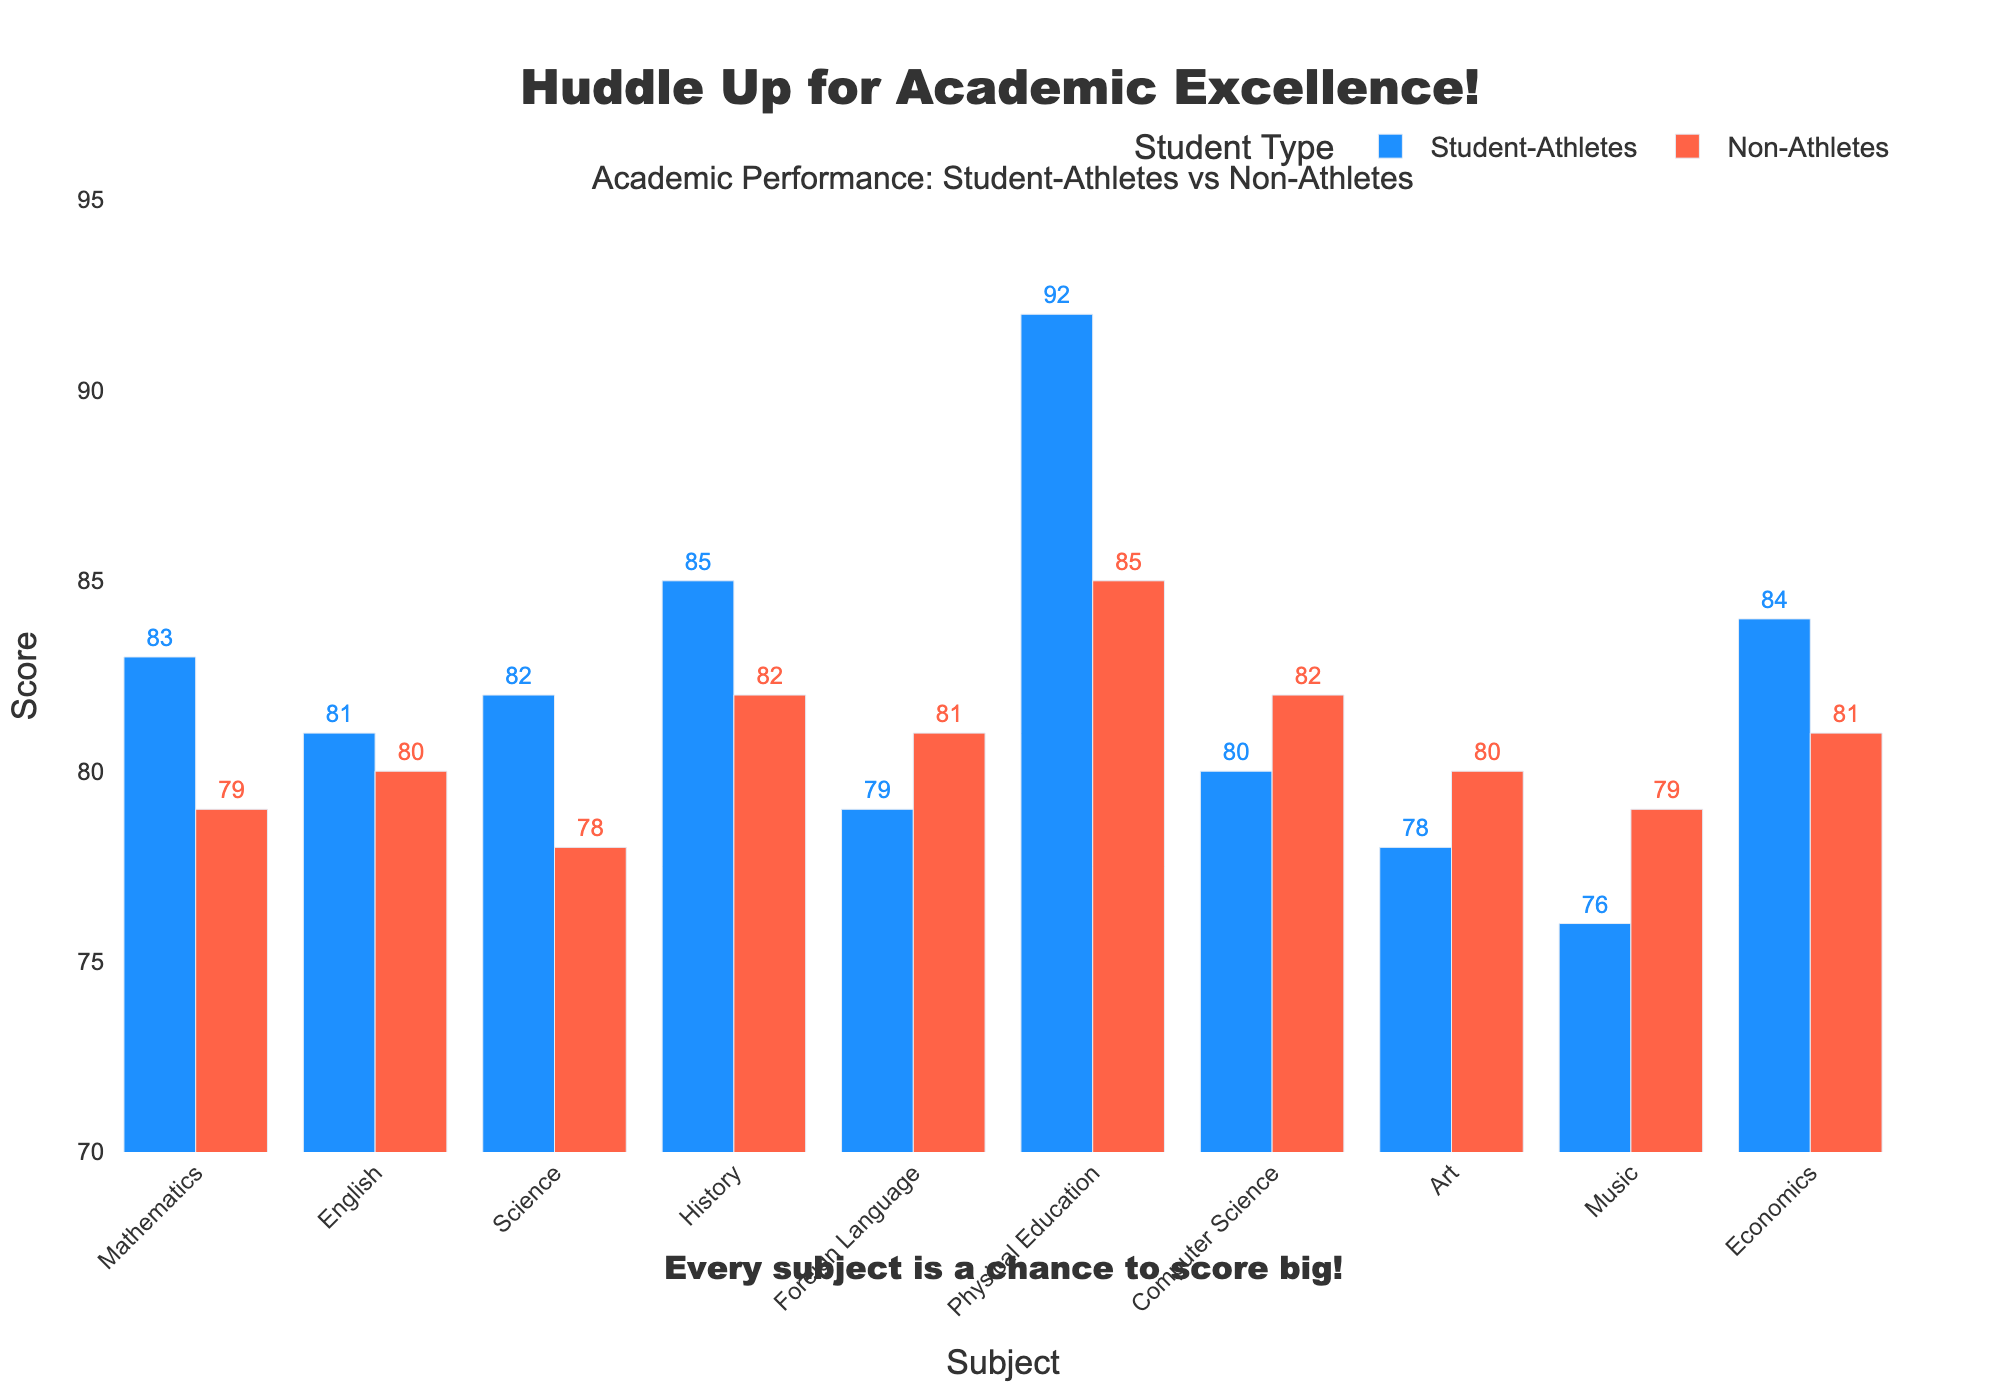what's the difference in scores between Student-Athletes and Non-Athletes in Physical Education? The bar for Student-Athletes in Physical Education reaches 92, while the bar for Non-Athletes reaches 85. The difference is 92 - 85.
Answer: 7 Which group has the highest score in Mathematics? The bar for Student-Athletes in Mathematics reaches 83, and the bar for Non-Athletes reaches 79. The highest score is 83.
Answer: Student-Athletes What is the total score for Student-Athletes in Mathematics, Science, and Economics? The scores are 83 for Mathematics, 82 for Science, and 84 for Economics. The total is 83 + 82 + 84.
Answer: 249 Are the scores in Art higher for Student-Athletes or Non-Athletes? The bar for Student-Athletes in Art reaches 78, while the bar for Non-Athletes reaches 80.
Answer: Non-Athletes By how many points do Non-Athletes outperform Student-Athletes in Computer Science? The bar for Non-Athletes in Computer Science reaches 82, while the bar for Student-Athletes reaches 80. The difference is 82 - 80.
Answer: 2 What's the median score of all subjects for Non-Athletes? The scores for Non-Athletes are 79, 80, 78, 82, 81, 85, 82, 80, 79, and 81. Arranged in ascending order: 78, 79, 79, 80, 80, 81, 81, 82, 82, 85. The median value is the average of the 5th and 6th scores (80 and 81).
Answer: 80.5 Which subject shows the smallest difference in scores between Student-Athletes and Non-Athletes? Evaluate the differences: Mathematics (4), English (1), Science (4), History (3), Foreign Language (2), Physical Education (7), Computer Science (2), Art (2), Music (3), Economics (3).
Answer: English In which subjects do Student-Athletes outperform Non-Athletes? Compare each subject visually: Mathematics, English, Science, History, Physical Education, Economics.
Answer: Mathematics, Science, History, Physical Education, Economics How much lower is the score for Student-Athletes in Music compared to the score in Physical Education? The bar for Student-Athletes in Music reaches 76, and the bar in Physical Education reaches 92. The difference is 92 - 76.
Answer: 16 What is the average score for Non-Athletes across all subjects? Sum the scores for Non-Athletes: 79, 80, 78, 82, 81, 85, 82, 80, 79, 81. The total is 727. Divide by the number of subjects (10).
Answer: 72.7 